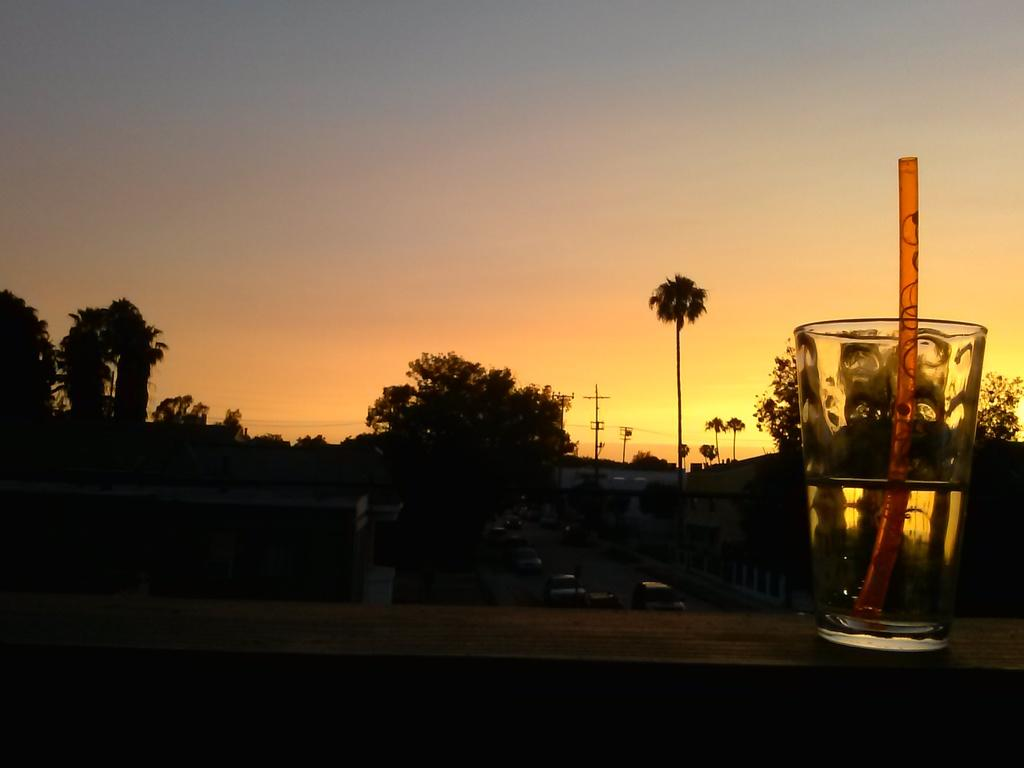What is in the glass that is visible in the image? There is a drink in the glass in the image. How might someone consume the drink in the glass? There is a straw in the glass, which can be used to drink the liquid. What type of natural environment can be seen in the image? Trees are visible in the image, suggesting a natural setting. What type of man-made structures are present in the image? There are buildings in the image, indicating an urban or developed area. What type of vertical structures are present in the image? There are poles in the image, which could be utility poles or other types of poles. What type of transportation is visible in the image? There are vehicles in the image, which could be cars, trucks, or other types of vehicles. What is visible in the background of the image? The sky is visible in the background of the image. How much sugar is in the tramp that is visible in the image? There is no tramp present in the image, and therefore no sugar can be associated with it. 